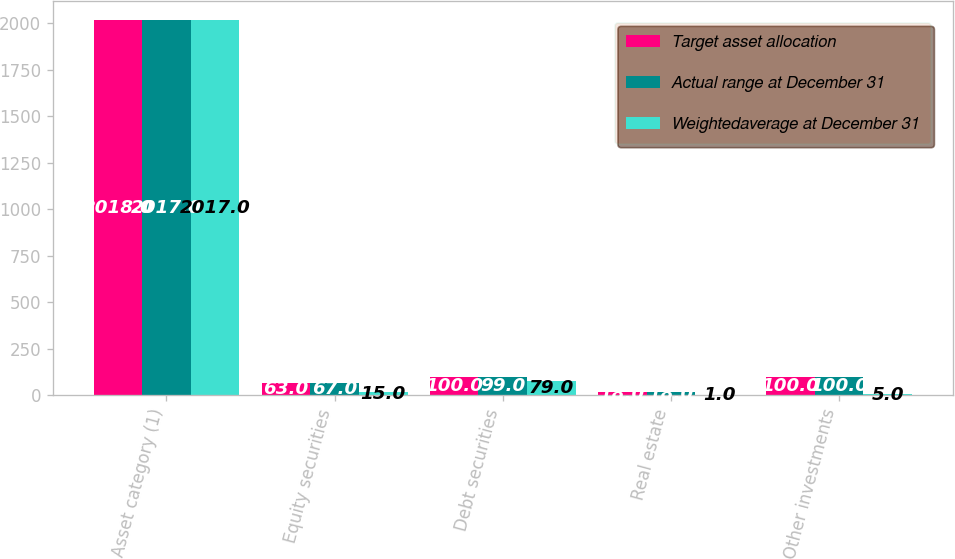Convert chart. <chart><loc_0><loc_0><loc_500><loc_500><stacked_bar_chart><ecel><fcel>Asset category (1)<fcel>Equity securities<fcel>Debt securities<fcel>Real estate<fcel>Other investments<nl><fcel>Target asset allocation<fcel>2018<fcel>63<fcel>100<fcel>18<fcel>100<nl><fcel>Actual range at December 31<fcel>2017<fcel>67<fcel>99<fcel>18<fcel>100<nl><fcel>Weightedaverage at December 31<fcel>2017<fcel>15<fcel>79<fcel>1<fcel>5<nl></chart> 